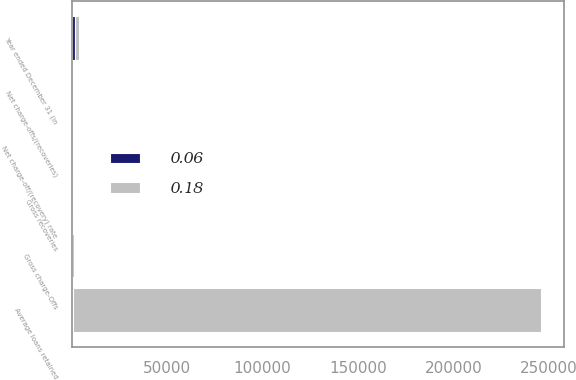<chart> <loc_0><loc_0><loc_500><loc_500><stacked_bar_chart><ecel><fcel>Year ended December 31 (in<fcel>Average loans retained<fcel>Gross charge-Offs<fcel>Gross recoveries<fcel>Net charge-offs/(recoveries)<fcel>Net charge-off/(recovery) rate<nl><fcel>0.06<fcel>2012<fcel>476<fcel>346<fcel>524<fcel>178<fcel>0.06<nl><fcel>0.18<fcel>2011<fcel>245111<fcel>916<fcel>476<fcel>440<fcel>0.18<nl></chart> 